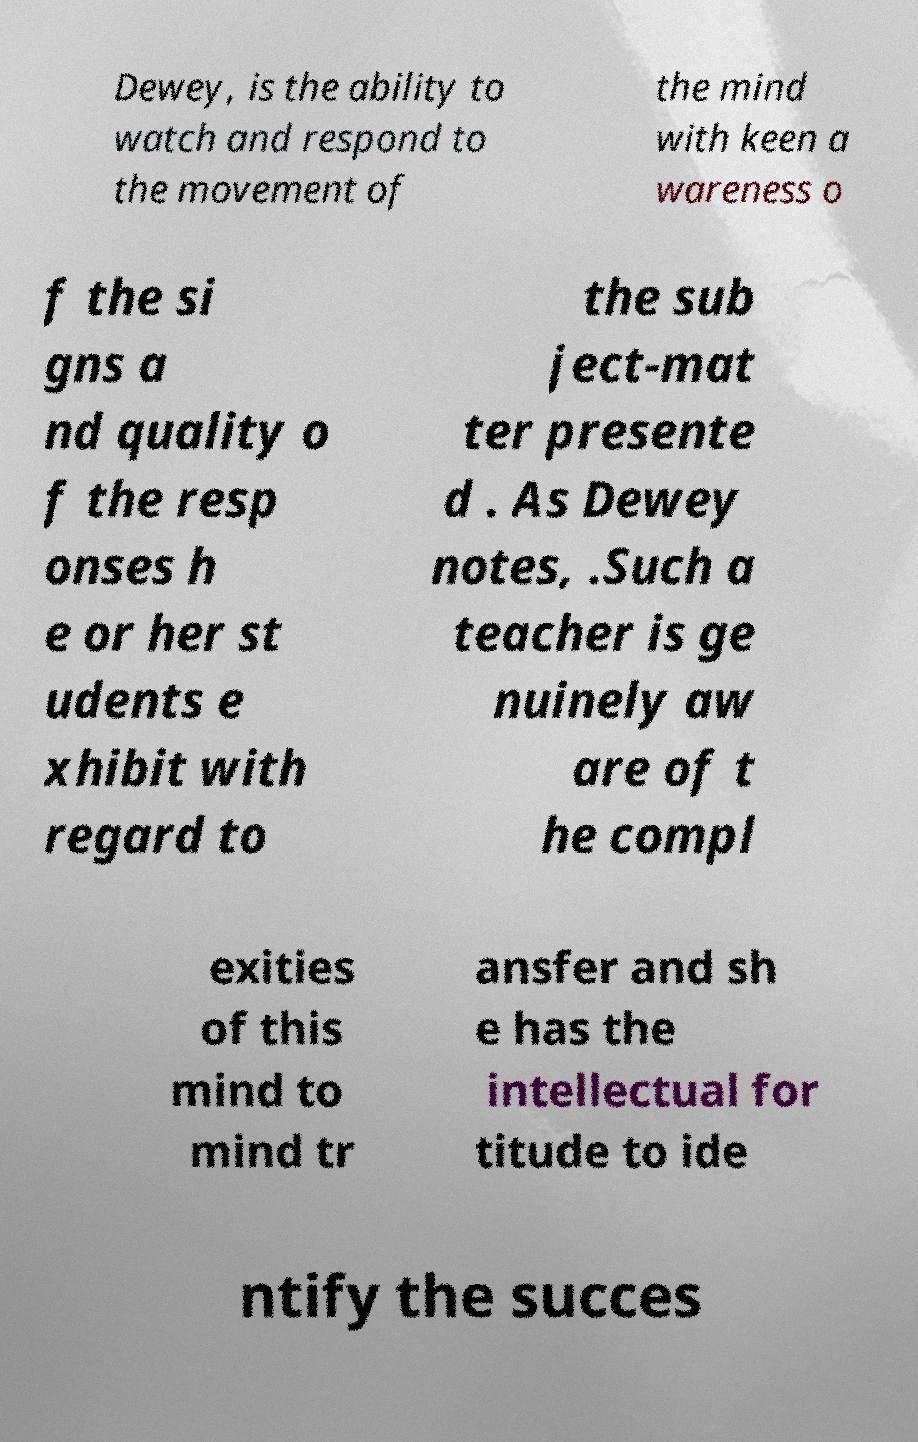Can you read and provide the text displayed in the image?This photo seems to have some interesting text. Can you extract and type it out for me? Dewey, is the ability to watch and respond to the movement of the mind with keen a wareness o f the si gns a nd quality o f the resp onses h e or her st udents e xhibit with regard to the sub ject-mat ter presente d . As Dewey notes, .Such a teacher is ge nuinely aw are of t he compl exities of this mind to mind tr ansfer and sh e has the intellectual for titude to ide ntify the succes 